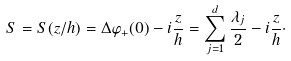<formula> <loc_0><loc_0><loc_500><loc_500>S = S ( z / h ) = \Delta \varphi _ { + } ( 0 ) - i \frac { z } { h } = \sum _ { j = 1 } ^ { d } \frac { \lambda _ { j } } 2 - i \frac { z } { h } \cdot</formula> 